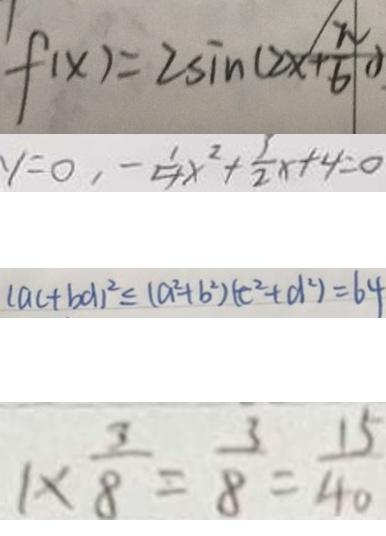<formula> <loc_0><loc_0><loc_500><loc_500>f ( x ) = 2 \sin ( 2 x + \frac { \pi } { 6 } ) 
 y = 0 , - \frac { 1 } { 4 } x ^ { 2 } + \frac { 3 } { 2 } x + 4 = 0 
 ( a c + b d ) ^ { 2 } \leq ( a ^ { 2 } + b ^ { 2 } ) ( c ^ { 2 } + d ^ { 2 } ) = 6 4 
 1 \times \frac { 3 } { 8 } = \frac { 3 } { 8 } = \frac { 1 5 } { 4 0 }</formula> 